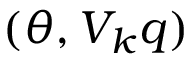<formula> <loc_0><loc_0><loc_500><loc_500>( \theta , V _ { k } q )</formula> 